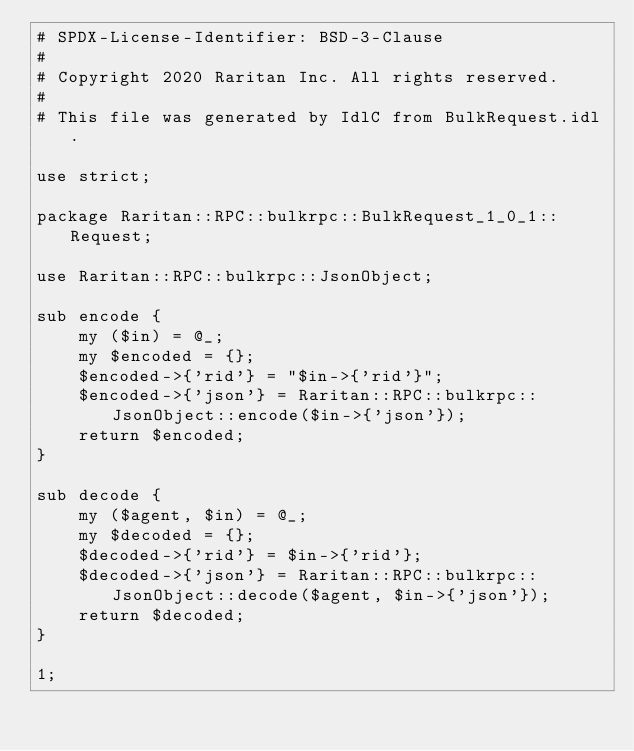Convert code to text. <code><loc_0><loc_0><loc_500><loc_500><_Perl_># SPDX-License-Identifier: BSD-3-Clause
#
# Copyright 2020 Raritan Inc. All rights reserved.
#
# This file was generated by IdlC from BulkRequest.idl.

use strict;

package Raritan::RPC::bulkrpc::BulkRequest_1_0_1::Request;

use Raritan::RPC::bulkrpc::JsonObject;

sub encode {
    my ($in) = @_;
    my $encoded = {};
    $encoded->{'rid'} = "$in->{'rid'}";
    $encoded->{'json'} = Raritan::RPC::bulkrpc::JsonObject::encode($in->{'json'});
    return $encoded;
}

sub decode {
    my ($agent, $in) = @_;
    my $decoded = {};
    $decoded->{'rid'} = $in->{'rid'};
    $decoded->{'json'} = Raritan::RPC::bulkrpc::JsonObject::decode($agent, $in->{'json'});
    return $decoded;
}

1;
</code> 